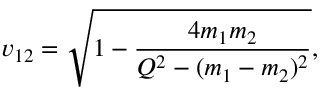<formula> <loc_0><loc_0><loc_500><loc_500>v _ { 1 2 } = \sqrt { 1 - \frac { 4 m _ { 1 } m _ { 2 } } { Q ^ { 2 } - ( m _ { 1 } - m _ { 2 } ) ^ { 2 } } } ,</formula> 